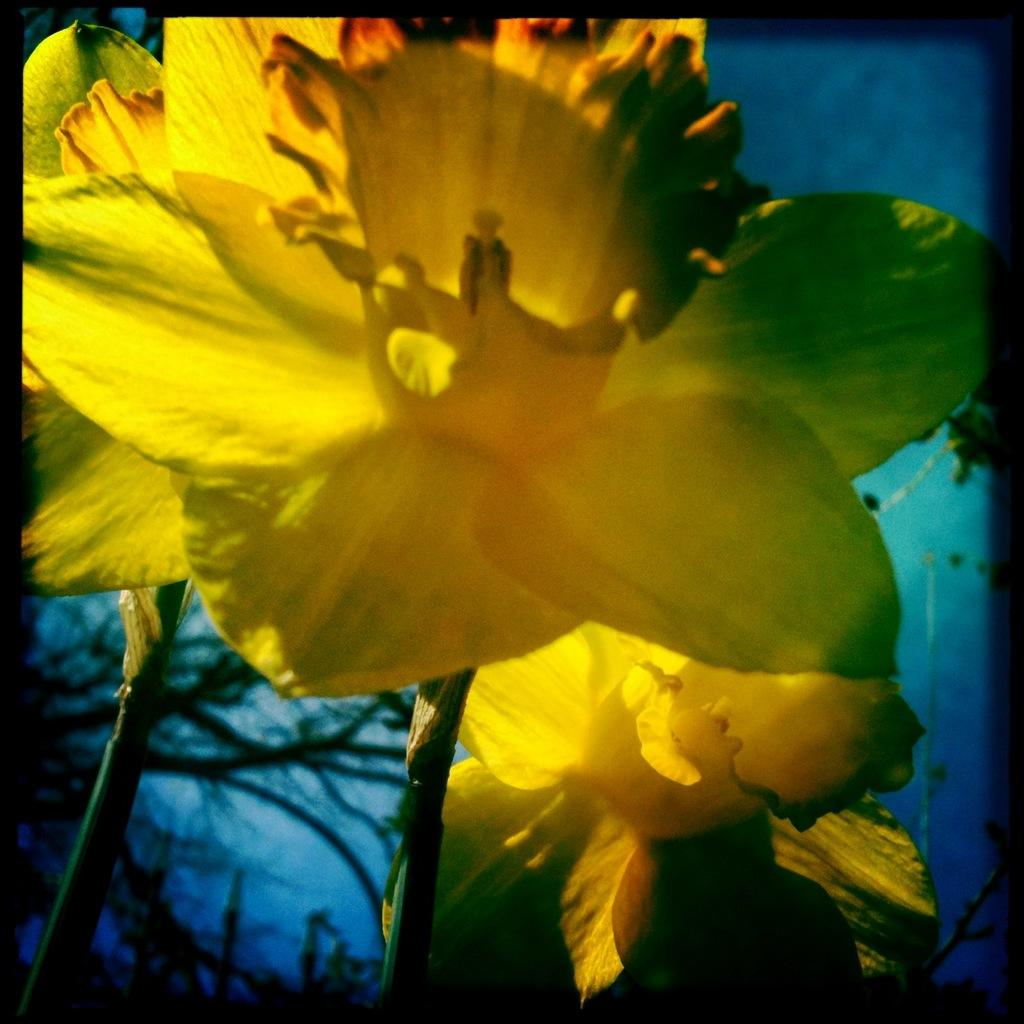What type of flora can be seen in the image? There are flowers and plants in the image. What color are the flowers in the image? The flowers are yellow in color. What color are the plants in the image? The plants are green in color. What can be seen in the background of the image? The background of the image is blue. Can you hear the voice of the father in the image? There is no voice or father present in the image, as it only features flowers, plants, and a blue background. 